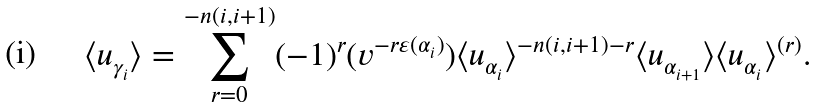Convert formula to latex. <formula><loc_0><loc_0><loc_500><loc_500>\langle u _ { \gamma _ { i } } \rangle = \sum _ { r = 0 } ^ { - n ( i , i + 1 ) } ( - 1 ) ^ { r } ( v ^ { - r \varepsilon ( \alpha _ { i } ) } ) \langle u _ { \alpha _ { i } } \rangle ^ { - n ( i , i + 1 ) - r } \langle u _ { \alpha _ { i + 1 } } \rangle \langle u _ { \alpha _ { i } } \rangle ^ { ( r ) } .</formula> 